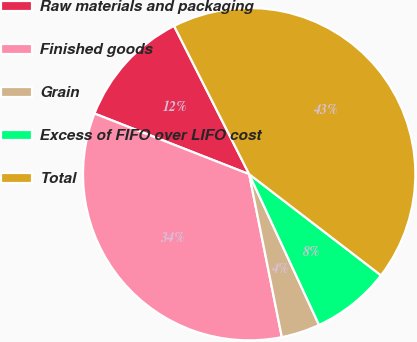Convert chart. <chart><loc_0><loc_0><loc_500><loc_500><pie_chart><fcel>Raw materials and packaging<fcel>Finished goods<fcel>Grain<fcel>Excess of FIFO over LIFO cost<fcel>Total<nl><fcel>11.59%<fcel>34.09%<fcel>3.76%<fcel>7.67%<fcel>42.88%<nl></chart> 